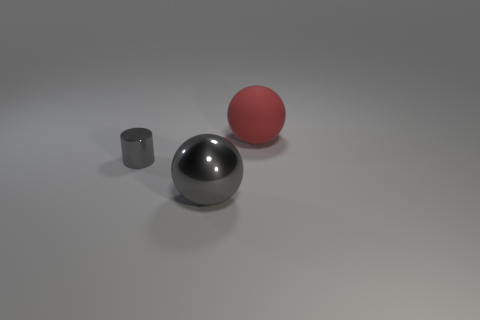Subtract all spheres. How many objects are left? 1 Add 3 blue things. How many objects exist? 6 Add 3 red rubber objects. How many red rubber objects are left? 4 Add 1 large gray things. How many large gray things exist? 2 Subtract 1 red balls. How many objects are left? 2 Subtract all cyan cylinders. Subtract all yellow cubes. How many cylinders are left? 1 Subtract all red balls. How many red cylinders are left? 0 Subtract all big gray balls. Subtract all large yellow cylinders. How many objects are left? 2 